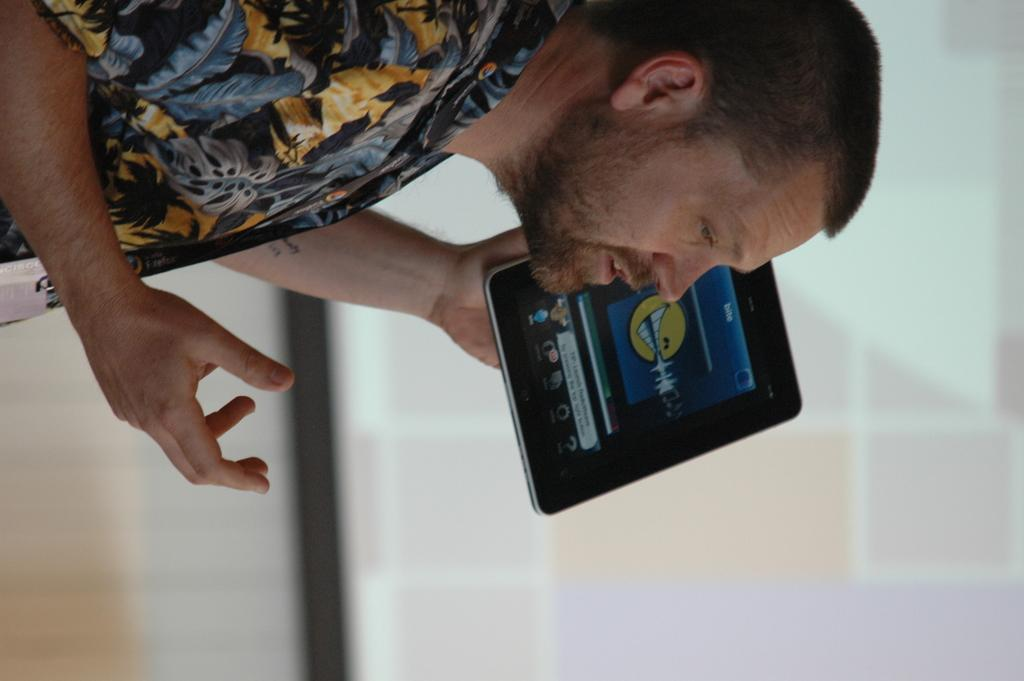Who is present in the image? There is a man in the image. What is the man holding in his hand? The man is holding a tab in his hand. Can you describe the background of the image? The background of the image is blurred. What can be seen in the background of the image? A screen is visible in the background of the image. What flavor of wall can be seen in the image? There is no wall present in the image, so it is not possible to determine the flavor of any wall. 